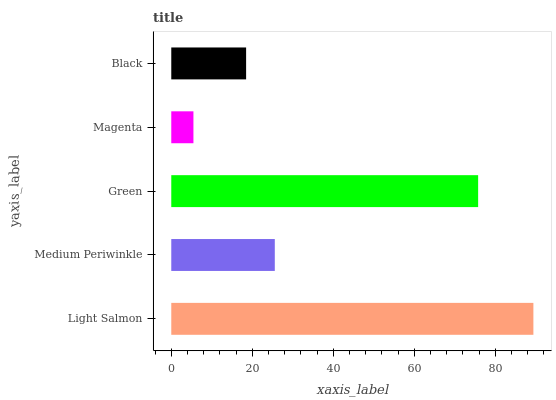Is Magenta the minimum?
Answer yes or no. Yes. Is Light Salmon the maximum?
Answer yes or no. Yes. Is Medium Periwinkle the minimum?
Answer yes or no. No. Is Medium Periwinkle the maximum?
Answer yes or no. No. Is Light Salmon greater than Medium Periwinkle?
Answer yes or no. Yes. Is Medium Periwinkle less than Light Salmon?
Answer yes or no. Yes. Is Medium Periwinkle greater than Light Salmon?
Answer yes or no. No. Is Light Salmon less than Medium Periwinkle?
Answer yes or no. No. Is Medium Periwinkle the high median?
Answer yes or no. Yes. Is Medium Periwinkle the low median?
Answer yes or no. Yes. Is Magenta the high median?
Answer yes or no. No. Is Black the low median?
Answer yes or no. No. 